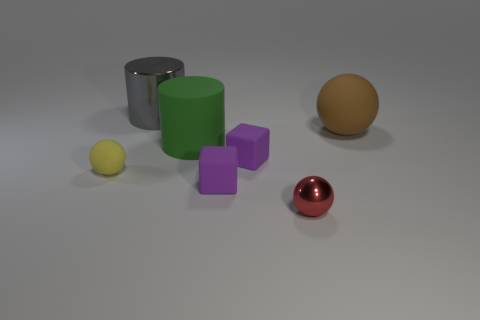What is the color of the tiny ball that is made of the same material as the large brown ball?
Provide a short and direct response. Yellow. Is the number of big green cylinders left of the green matte cylinder less than the number of small matte blocks?
Offer a very short reply. Yes. There is a shiny thing behind the large rubber thing right of the metallic thing in front of the brown matte thing; how big is it?
Your answer should be compact. Large. Is the big object that is on the right side of the red metal thing made of the same material as the large gray cylinder?
Offer a very short reply. No. What number of objects are either small cyan cylinders or brown rubber spheres?
Your response must be concise. 1. What size is the yellow matte object that is the same shape as the red object?
Give a very brief answer. Small. How many other things are the same color as the metallic sphere?
Keep it short and to the point. 0. What number of cylinders are tiny red things or yellow rubber objects?
Provide a short and direct response. 0. The big rubber object that is in front of the rubber sphere that is on the right side of the metal sphere is what color?
Give a very brief answer. Green. There is a small shiny object; what shape is it?
Your answer should be compact. Sphere. 